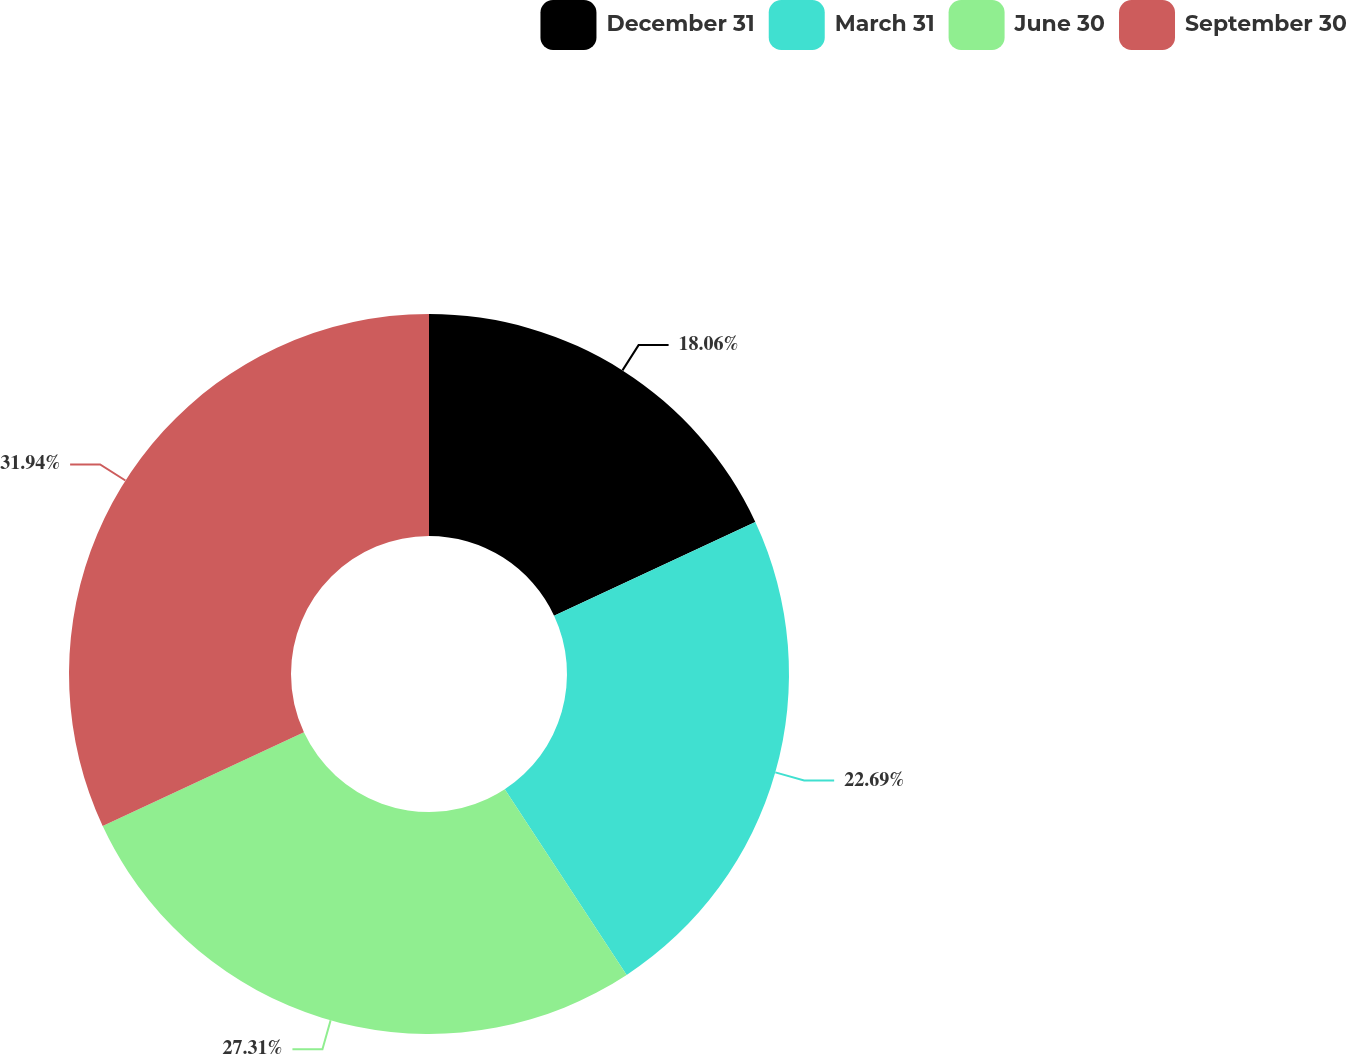Convert chart to OTSL. <chart><loc_0><loc_0><loc_500><loc_500><pie_chart><fcel>December 31<fcel>March 31<fcel>June 30<fcel>September 30<nl><fcel>18.06%<fcel>22.69%<fcel>27.31%<fcel>31.94%<nl></chart> 